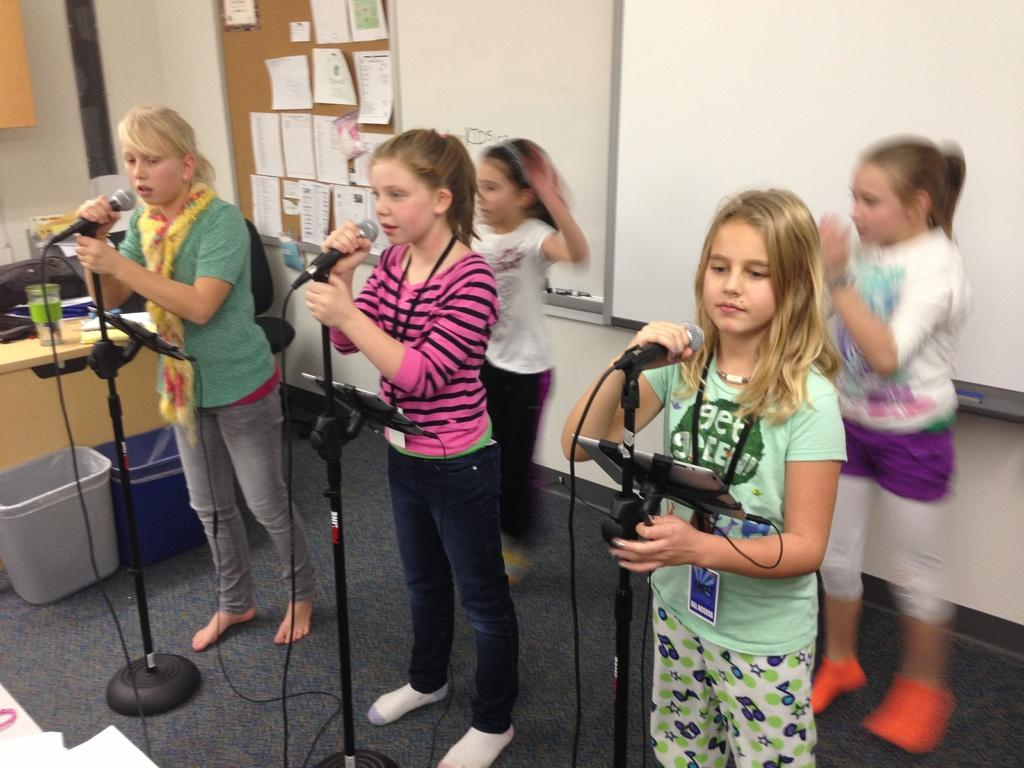Who or what can be seen in the image? There are people in the image. Where are the people located? The people are standing on the floor. What are the people holding in their hands? The people are holding microphones. What are the people doing with the microphones? The people are singing. What is the temperature of the room where the people are singing? The provided facts do not mention the temperature of the room, so it cannot be determined from the image. 